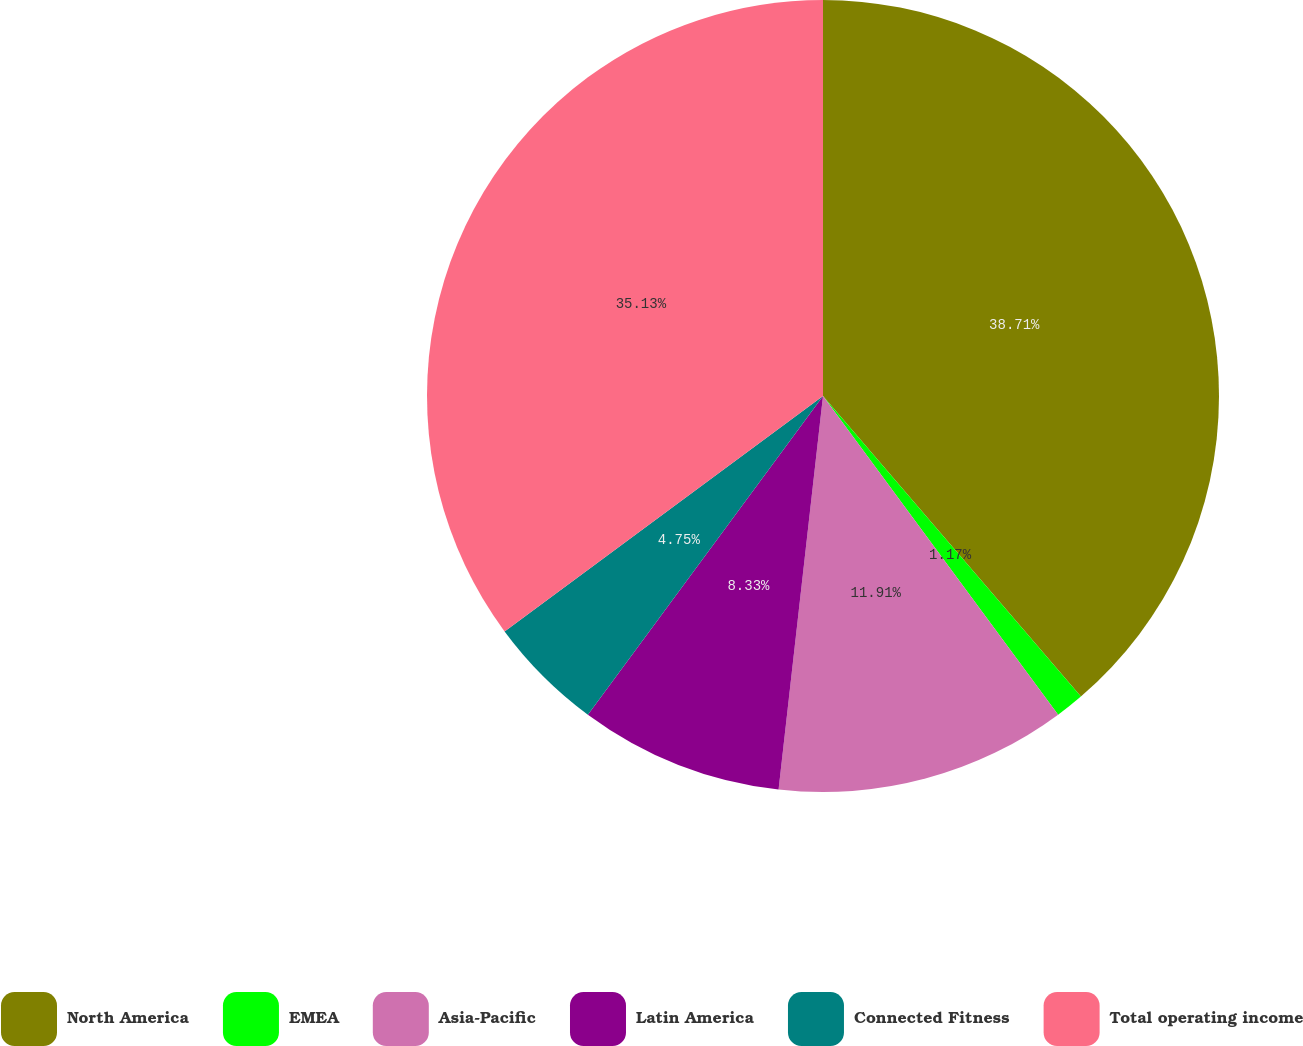Convert chart. <chart><loc_0><loc_0><loc_500><loc_500><pie_chart><fcel>North America<fcel>EMEA<fcel>Asia-Pacific<fcel>Latin America<fcel>Connected Fitness<fcel>Total operating income<nl><fcel>38.72%<fcel>1.17%<fcel>11.91%<fcel>8.33%<fcel>4.75%<fcel>35.14%<nl></chart> 